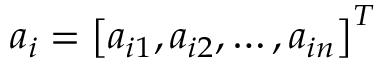Convert formula to latex. <formula><loc_0><loc_0><loc_500><loc_500>a _ { i } = \left [ a _ { i 1 } , a _ { i 2 } , \dots , a _ { i n } \right ] ^ { T }</formula> 